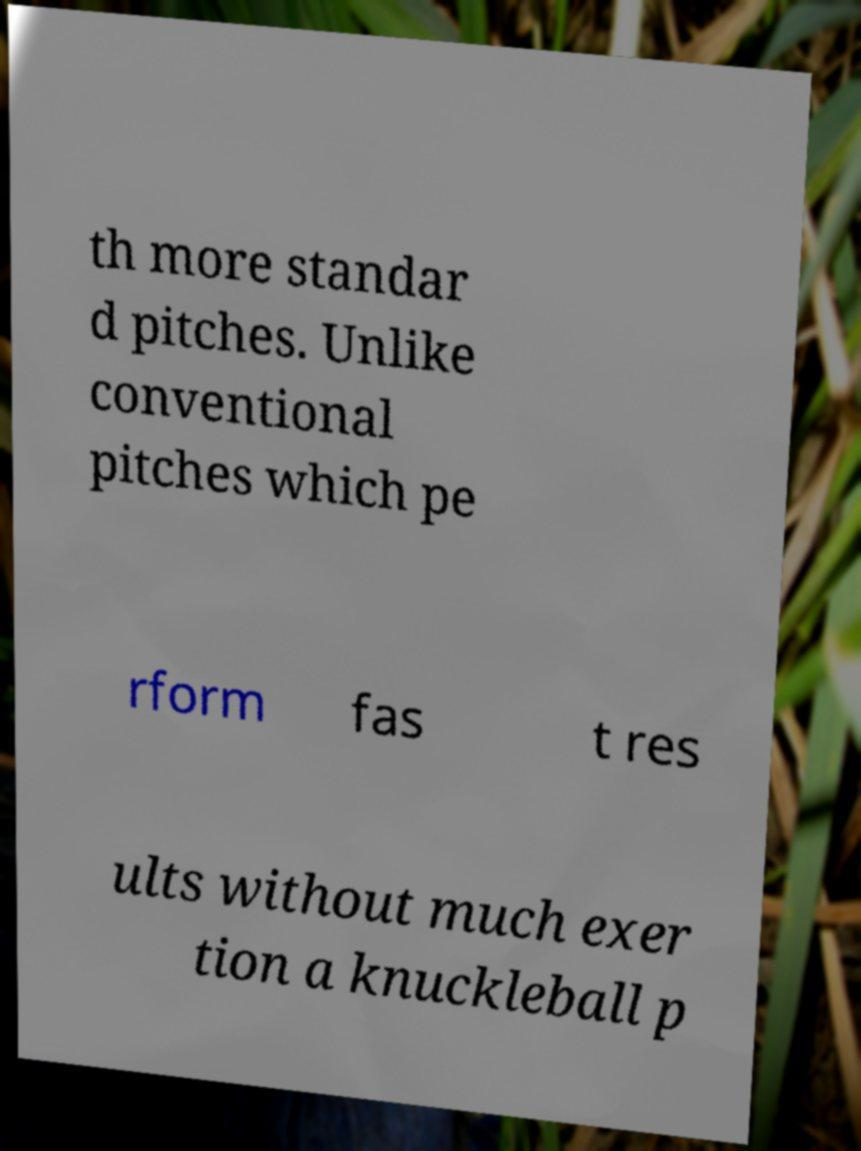Can you accurately transcribe the text from the provided image for me? th more standar d pitches. Unlike conventional pitches which pe rform fas t res ults without much exer tion a knuckleball p 